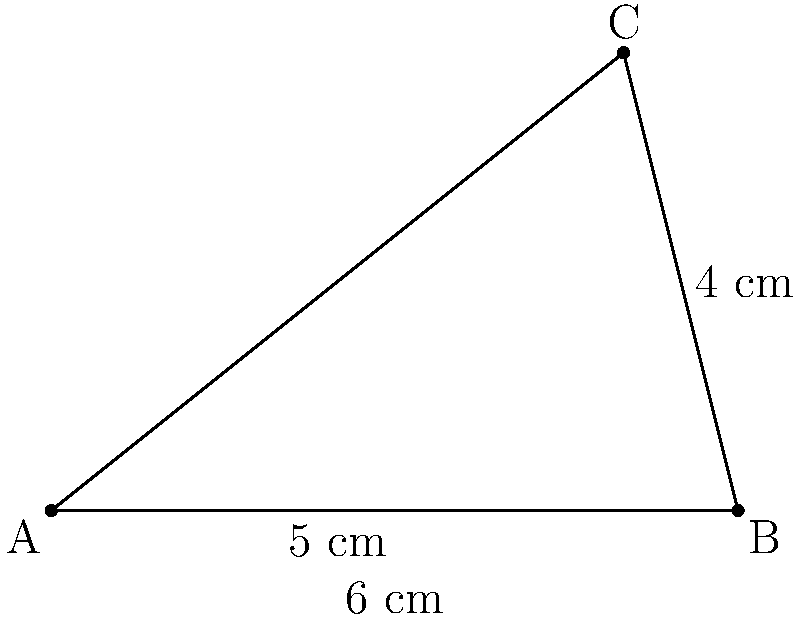You are examining an irregularly shaped piece of parchment from a 15th-century manuscript. The parchment can be approximated as a triangle with sides measuring 5 cm, 6 cm, and 4 cm, as shown in the diagram. Calculate the area of this parchment using Heron's formula. Round your answer to the nearest square centimeter. To calculate the area of the triangular parchment, we'll use Heron's formula:

1) Heron's formula states that the area $A$ of a triangle with sides $a$, $b$, and $c$ is:
   
   $A = \sqrt{s(s-a)(s-b)(s-c)}$

   where $s$ is the semi-perimeter: $s = \frac{a + b + c}{2}$

2) In this case, $a = 5$ cm, $b = 6$ cm, and $c = 4$ cm

3) Calculate the semi-perimeter:
   $s = \frac{5 + 6 + 4}{2} = \frac{15}{2} = 7.5$ cm

4) Now, substitute these values into Heron's formula:
   $A = \sqrt{7.5(7.5-5)(7.5-6)(7.5-4)}$

5) Simplify:
   $A = \sqrt{7.5 \times 2.5 \times 1.5 \times 3.5}$

6) Calculate:
   $A = \sqrt{98.4375} \approx 9.92$ cm²

7) Rounding to the nearest square centimeter:
   $A \approx 10$ cm²
Answer: 10 cm² 